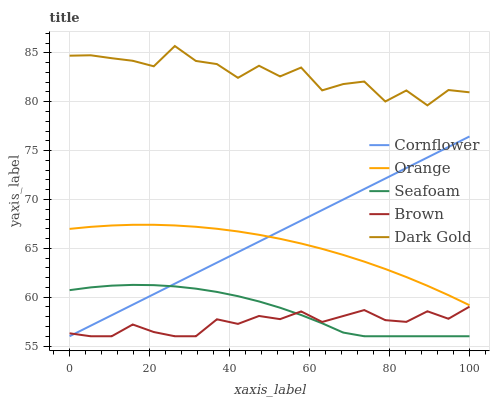Does Brown have the minimum area under the curve?
Answer yes or no. Yes. Does Dark Gold have the maximum area under the curve?
Answer yes or no. Yes. Does Cornflower have the minimum area under the curve?
Answer yes or no. No. Does Cornflower have the maximum area under the curve?
Answer yes or no. No. Is Cornflower the smoothest?
Answer yes or no. Yes. Is Dark Gold the roughest?
Answer yes or no. Yes. Is Dark Gold the smoothest?
Answer yes or no. No. Is Cornflower the roughest?
Answer yes or no. No. Does Cornflower have the lowest value?
Answer yes or no. Yes. Does Dark Gold have the lowest value?
Answer yes or no. No. Does Dark Gold have the highest value?
Answer yes or no. Yes. Does Cornflower have the highest value?
Answer yes or no. No. Is Brown less than Dark Gold?
Answer yes or no. Yes. Is Dark Gold greater than Brown?
Answer yes or no. Yes. Does Seafoam intersect Brown?
Answer yes or no. Yes. Is Seafoam less than Brown?
Answer yes or no. No. Is Seafoam greater than Brown?
Answer yes or no. No. Does Brown intersect Dark Gold?
Answer yes or no. No. 